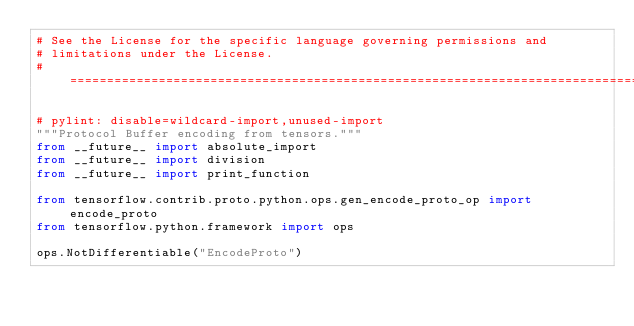Convert code to text. <code><loc_0><loc_0><loc_500><loc_500><_Python_># See the License for the specific language governing permissions and
# limitations under the License.
# =============================================================================

# pylint: disable=wildcard-import,unused-import
"""Protocol Buffer encoding from tensors."""
from __future__ import absolute_import
from __future__ import division
from __future__ import print_function

from tensorflow.contrib.proto.python.ops.gen_encode_proto_op import encode_proto
from tensorflow.python.framework import ops

ops.NotDifferentiable("EncodeProto")
</code> 